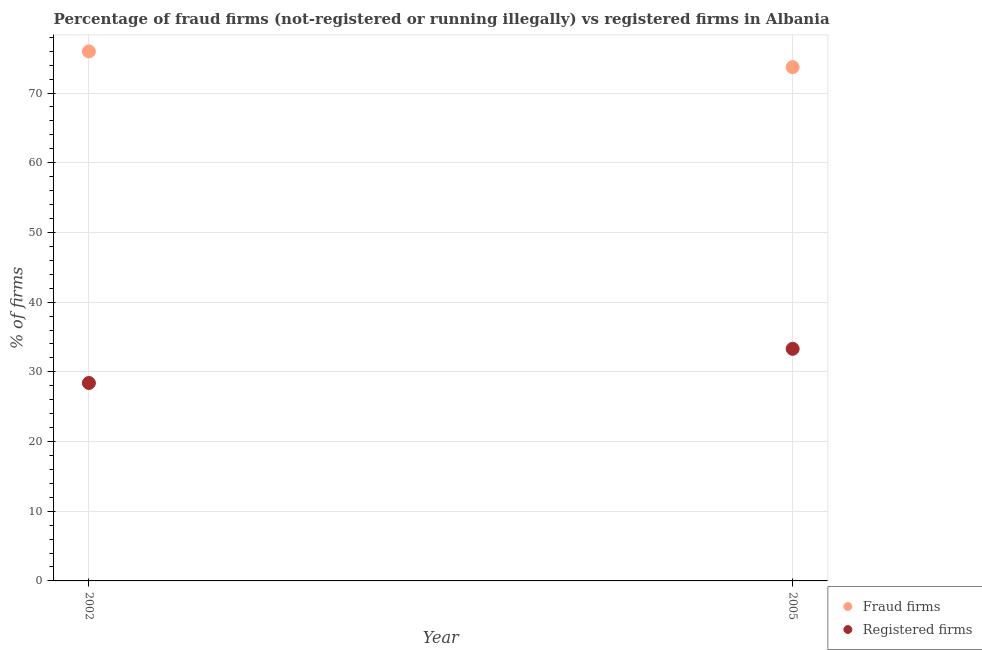What is the percentage of fraud firms in 2002?
Give a very brief answer. 75.97. Across all years, what is the maximum percentage of registered firms?
Your response must be concise. 33.3. Across all years, what is the minimum percentage of fraud firms?
Your answer should be very brief. 73.72. In which year was the percentage of registered firms minimum?
Provide a short and direct response. 2002. What is the total percentage of fraud firms in the graph?
Give a very brief answer. 149.69. What is the difference between the percentage of registered firms in 2002 and that in 2005?
Your answer should be compact. -4.9. What is the difference between the percentage of fraud firms in 2002 and the percentage of registered firms in 2005?
Provide a succinct answer. 42.67. What is the average percentage of fraud firms per year?
Provide a short and direct response. 74.84. In the year 2005, what is the difference between the percentage of registered firms and percentage of fraud firms?
Your answer should be compact. -40.42. In how many years, is the percentage of registered firms greater than 18 %?
Make the answer very short. 2. What is the ratio of the percentage of fraud firms in 2002 to that in 2005?
Make the answer very short. 1.03. In how many years, is the percentage of registered firms greater than the average percentage of registered firms taken over all years?
Offer a terse response. 1. Does the percentage of fraud firms monotonically increase over the years?
Give a very brief answer. No. Is the percentage of fraud firms strictly less than the percentage of registered firms over the years?
Provide a short and direct response. No. How many dotlines are there?
Offer a very short reply. 2. What is the difference between two consecutive major ticks on the Y-axis?
Ensure brevity in your answer.  10. Are the values on the major ticks of Y-axis written in scientific E-notation?
Provide a succinct answer. No. Does the graph contain any zero values?
Keep it short and to the point. No. Does the graph contain grids?
Offer a very short reply. Yes. Where does the legend appear in the graph?
Make the answer very short. Bottom right. What is the title of the graph?
Keep it short and to the point. Percentage of fraud firms (not-registered or running illegally) vs registered firms in Albania. What is the label or title of the Y-axis?
Provide a succinct answer. % of firms. What is the % of firms in Fraud firms in 2002?
Give a very brief answer. 75.97. What is the % of firms of Registered firms in 2002?
Your answer should be very brief. 28.4. What is the % of firms of Fraud firms in 2005?
Provide a short and direct response. 73.72. What is the % of firms in Registered firms in 2005?
Provide a short and direct response. 33.3. Across all years, what is the maximum % of firms of Fraud firms?
Provide a succinct answer. 75.97. Across all years, what is the maximum % of firms in Registered firms?
Give a very brief answer. 33.3. Across all years, what is the minimum % of firms in Fraud firms?
Offer a very short reply. 73.72. Across all years, what is the minimum % of firms of Registered firms?
Provide a short and direct response. 28.4. What is the total % of firms of Fraud firms in the graph?
Offer a very short reply. 149.69. What is the total % of firms in Registered firms in the graph?
Give a very brief answer. 61.7. What is the difference between the % of firms of Fraud firms in 2002 and that in 2005?
Keep it short and to the point. 2.25. What is the difference between the % of firms in Fraud firms in 2002 and the % of firms in Registered firms in 2005?
Provide a short and direct response. 42.67. What is the average % of firms in Fraud firms per year?
Provide a succinct answer. 74.84. What is the average % of firms of Registered firms per year?
Keep it short and to the point. 30.85. In the year 2002, what is the difference between the % of firms in Fraud firms and % of firms in Registered firms?
Provide a short and direct response. 47.57. In the year 2005, what is the difference between the % of firms of Fraud firms and % of firms of Registered firms?
Offer a very short reply. 40.42. What is the ratio of the % of firms of Fraud firms in 2002 to that in 2005?
Provide a succinct answer. 1.03. What is the ratio of the % of firms in Registered firms in 2002 to that in 2005?
Your answer should be compact. 0.85. What is the difference between the highest and the second highest % of firms of Fraud firms?
Provide a succinct answer. 2.25. What is the difference between the highest and the second highest % of firms of Registered firms?
Give a very brief answer. 4.9. What is the difference between the highest and the lowest % of firms of Fraud firms?
Ensure brevity in your answer.  2.25. What is the difference between the highest and the lowest % of firms of Registered firms?
Provide a short and direct response. 4.9. 